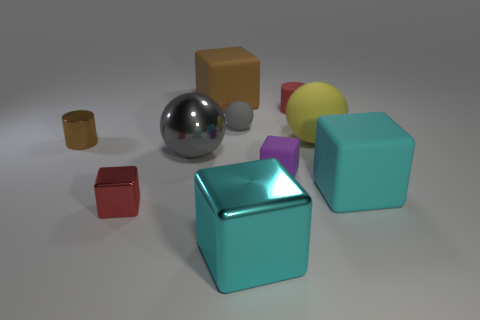Are any brown objects visible?
Make the answer very short. Yes. How many things are either small blocks or cyan shiny cubes in front of the purple cube?
Keep it short and to the point. 3. Do the gray sphere behind the brown shiny cylinder and the big gray metallic sphere have the same size?
Keep it short and to the point. No. What number of other objects are there of the same size as the red matte cylinder?
Offer a terse response. 4. What is the color of the metal cylinder?
Your answer should be compact. Brown. There is a gray sphere in front of the large yellow matte object; what material is it?
Keep it short and to the point. Metal. Are there the same number of big cyan things to the left of the gray metal ball and big gray spheres?
Provide a short and direct response. No. Is the shape of the large brown thing the same as the large cyan shiny object?
Your answer should be compact. Yes. Is there anything else that is the same color as the large matte ball?
Offer a very short reply. No. What shape is the large thing that is both to the left of the red cylinder and in front of the purple cube?
Your answer should be compact. Cube. 